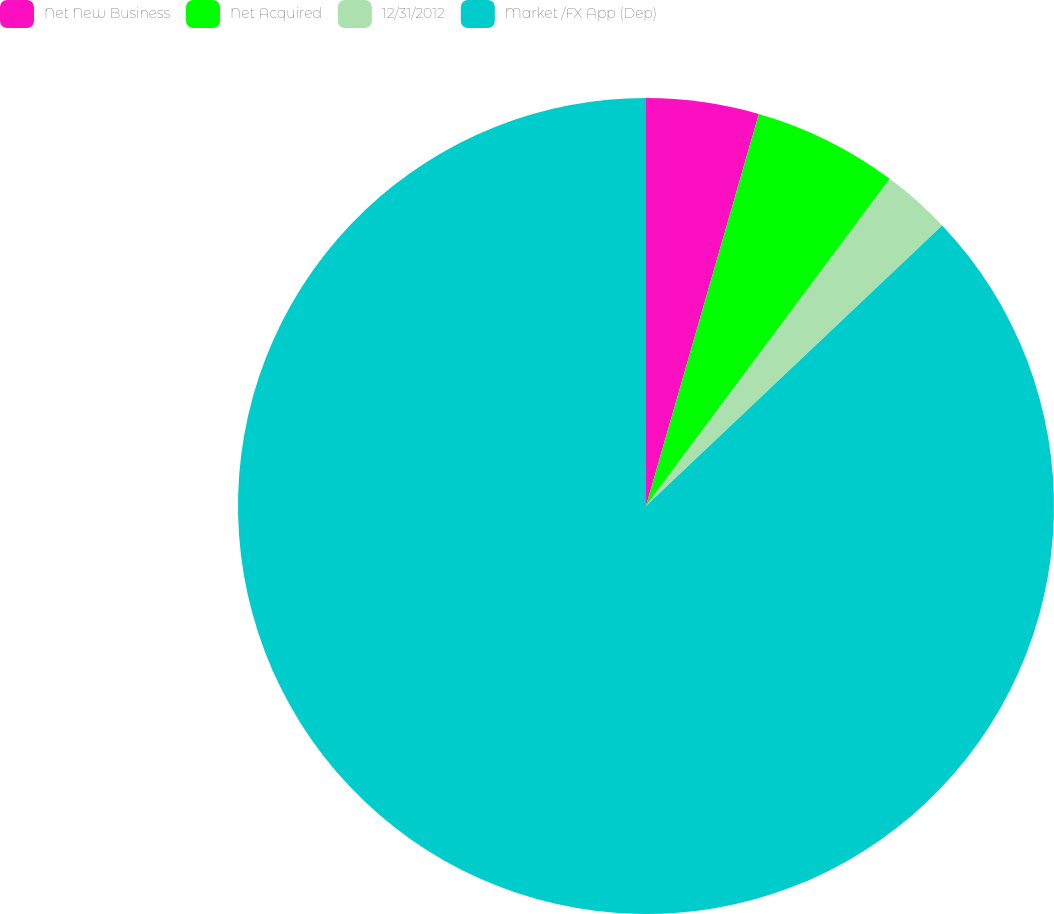<chart> <loc_0><loc_0><loc_500><loc_500><pie_chart><fcel>Net New Business<fcel>Net Acquired<fcel>12/31/2012<fcel>Market /FX App (Dep)<nl><fcel>4.46%<fcel>5.73%<fcel>2.74%<fcel>87.07%<nl></chart> 